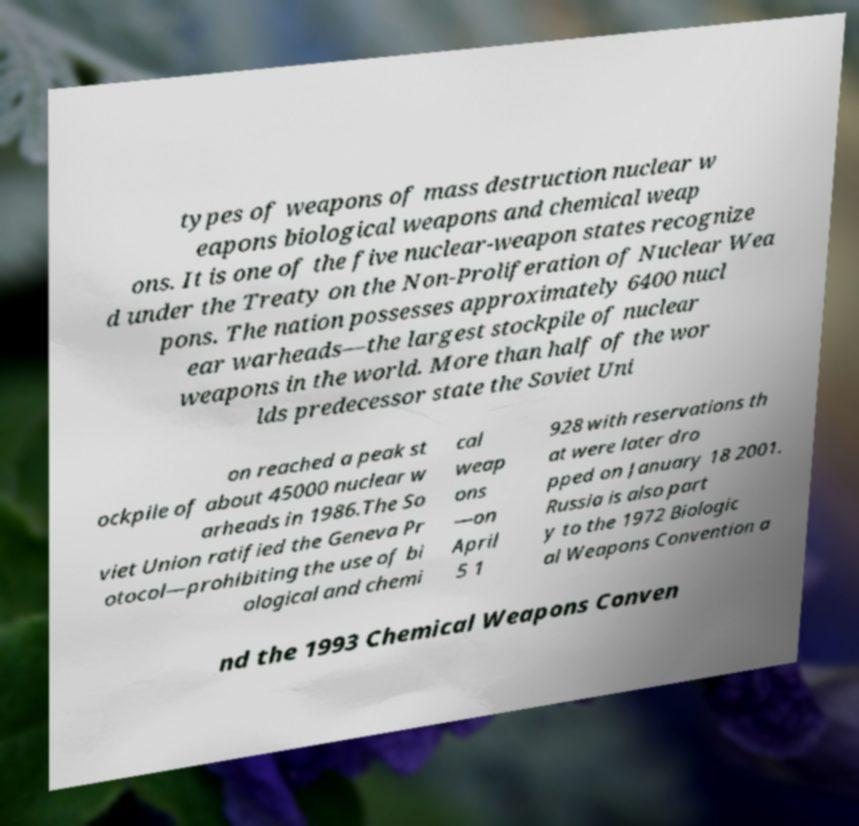Can you read and provide the text displayed in the image?This photo seems to have some interesting text. Can you extract and type it out for me? types of weapons of mass destruction nuclear w eapons biological weapons and chemical weap ons. It is one of the five nuclear-weapon states recognize d under the Treaty on the Non-Proliferation of Nuclear Wea pons. The nation possesses approximately 6400 nucl ear warheads—the largest stockpile of nuclear weapons in the world. More than half of the wor lds predecessor state the Soviet Uni on reached a peak st ockpile of about 45000 nuclear w arheads in 1986.The So viet Union ratified the Geneva Pr otocol—prohibiting the use of bi ological and chemi cal weap ons —on April 5 1 928 with reservations th at were later dro pped on January 18 2001. Russia is also part y to the 1972 Biologic al Weapons Convention a nd the 1993 Chemical Weapons Conven 